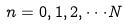<formula> <loc_0><loc_0><loc_500><loc_500>n = 0 , 1 , 2 , \cdot \cdot \cdot N</formula> 